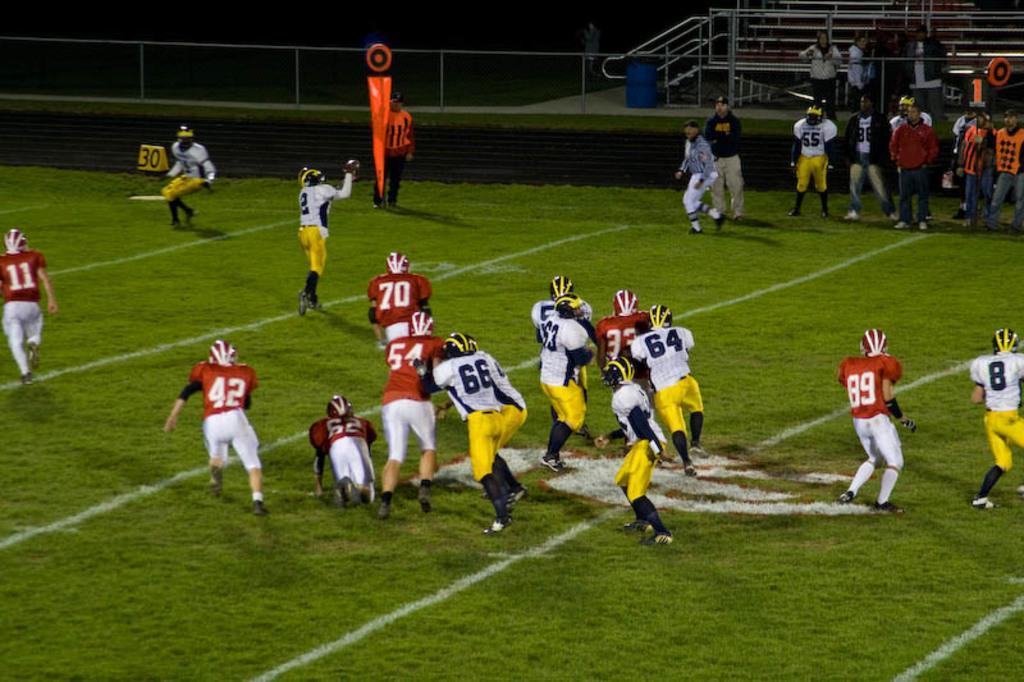Could you give a brief overview of what you see in this image? In the picture we can see a playground on it we can see some people are in sports wear and helmets and they are running here and there and besides to them we can see some people are standing and behind them we can see a fencing and behind it we can see a railing. 